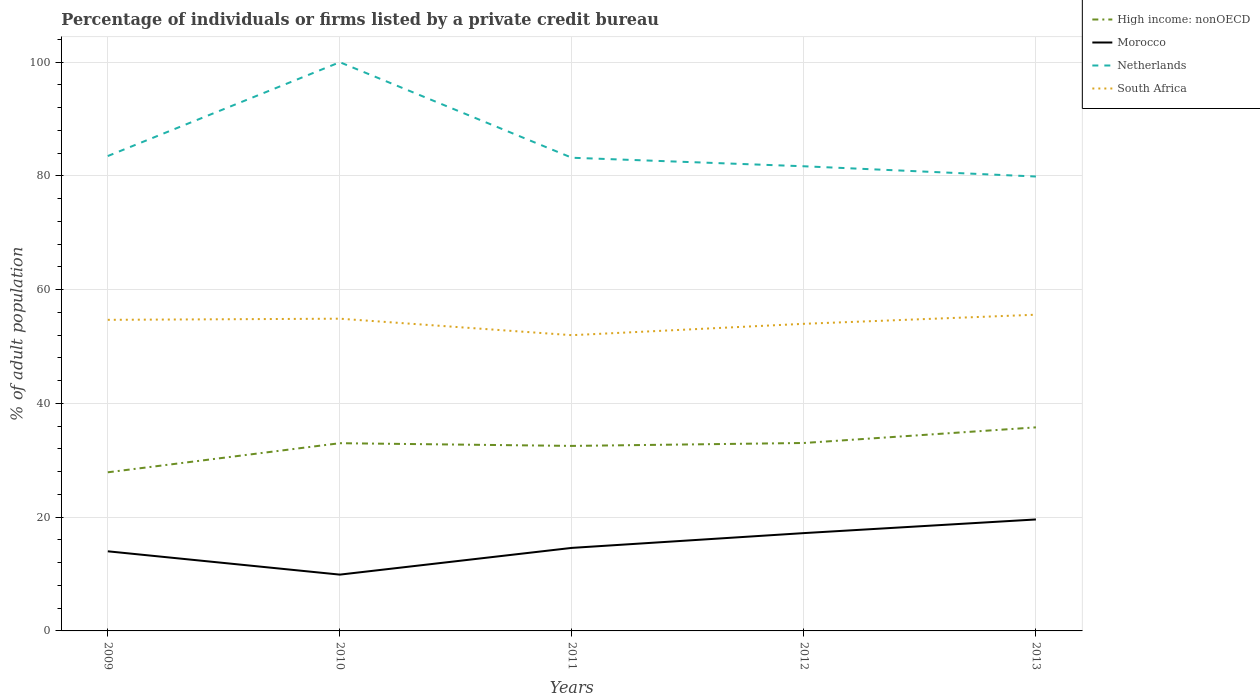How many different coloured lines are there?
Make the answer very short. 4. Across all years, what is the maximum percentage of population listed by a private credit bureau in Morocco?
Provide a succinct answer. 9.9. In which year was the percentage of population listed by a private credit bureau in Netherlands maximum?
Your response must be concise. 2013. What is the total percentage of population listed by a private credit bureau in High income: nonOECD in the graph?
Make the answer very short. -2.78. What is the difference between the highest and the second highest percentage of population listed by a private credit bureau in Netherlands?
Offer a very short reply. 20.1. What is the difference between the highest and the lowest percentage of population listed by a private credit bureau in South Africa?
Give a very brief answer. 3. Is the percentage of population listed by a private credit bureau in High income: nonOECD strictly greater than the percentage of population listed by a private credit bureau in Morocco over the years?
Your answer should be compact. No. How many lines are there?
Make the answer very short. 4. Are the values on the major ticks of Y-axis written in scientific E-notation?
Provide a succinct answer. No. What is the title of the graph?
Your answer should be compact. Percentage of individuals or firms listed by a private credit bureau. Does "Bahrain" appear as one of the legend labels in the graph?
Keep it short and to the point. No. What is the label or title of the X-axis?
Keep it short and to the point. Years. What is the label or title of the Y-axis?
Offer a terse response. % of adult population. What is the % of adult population of High income: nonOECD in 2009?
Offer a terse response. 27.89. What is the % of adult population in Morocco in 2009?
Your answer should be very brief. 14. What is the % of adult population in Netherlands in 2009?
Make the answer very short. 83.5. What is the % of adult population of South Africa in 2009?
Provide a short and direct response. 54.7. What is the % of adult population of High income: nonOECD in 2010?
Your response must be concise. 33.01. What is the % of adult population in Morocco in 2010?
Give a very brief answer. 9.9. What is the % of adult population in Netherlands in 2010?
Give a very brief answer. 100. What is the % of adult population in South Africa in 2010?
Provide a short and direct response. 54.9. What is the % of adult population of High income: nonOECD in 2011?
Keep it short and to the point. 32.53. What is the % of adult population of Morocco in 2011?
Ensure brevity in your answer.  14.6. What is the % of adult population in Netherlands in 2011?
Make the answer very short. 83.2. What is the % of adult population of South Africa in 2011?
Your answer should be very brief. 52. What is the % of adult population in High income: nonOECD in 2012?
Provide a short and direct response. 33.04. What is the % of adult population of Netherlands in 2012?
Your answer should be compact. 81.7. What is the % of adult population of South Africa in 2012?
Your response must be concise. 54. What is the % of adult population in High income: nonOECD in 2013?
Keep it short and to the point. 35.79. What is the % of adult population in Morocco in 2013?
Provide a succinct answer. 19.6. What is the % of adult population in Netherlands in 2013?
Your answer should be very brief. 79.9. What is the % of adult population in South Africa in 2013?
Provide a succinct answer. 55.6. Across all years, what is the maximum % of adult population of High income: nonOECD?
Ensure brevity in your answer.  35.79. Across all years, what is the maximum % of adult population of Morocco?
Provide a short and direct response. 19.6. Across all years, what is the maximum % of adult population in South Africa?
Your answer should be compact. 55.6. Across all years, what is the minimum % of adult population in High income: nonOECD?
Your response must be concise. 27.89. Across all years, what is the minimum % of adult population of Morocco?
Make the answer very short. 9.9. Across all years, what is the minimum % of adult population in Netherlands?
Keep it short and to the point. 79.9. What is the total % of adult population of High income: nonOECD in the graph?
Offer a very short reply. 162.27. What is the total % of adult population of Morocco in the graph?
Provide a succinct answer. 75.3. What is the total % of adult population in Netherlands in the graph?
Give a very brief answer. 428.3. What is the total % of adult population in South Africa in the graph?
Make the answer very short. 271.2. What is the difference between the % of adult population of High income: nonOECD in 2009 and that in 2010?
Keep it short and to the point. -5.12. What is the difference between the % of adult population in Morocco in 2009 and that in 2010?
Give a very brief answer. 4.1. What is the difference between the % of adult population of Netherlands in 2009 and that in 2010?
Provide a short and direct response. -16.5. What is the difference between the % of adult population of High income: nonOECD in 2009 and that in 2011?
Make the answer very short. -4.64. What is the difference between the % of adult population in Morocco in 2009 and that in 2011?
Your response must be concise. -0.6. What is the difference between the % of adult population in South Africa in 2009 and that in 2011?
Your answer should be compact. 2.7. What is the difference between the % of adult population of High income: nonOECD in 2009 and that in 2012?
Provide a succinct answer. -5.15. What is the difference between the % of adult population in Netherlands in 2009 and that in 2012?
Ensure brevity in your answer.  1.8. What is the difference between the % of adult population in High income: nonOECD in 2009 and that in 2013?
Offer a terse response. -7.9. What is the difference between the % of adult population in Morocco in 2009 and that in 2013?
Give a very brief answer. -5.6. What is the difference between the % of adult population in South Africa in 2009 and that in 2013?
Make the answer very short. -0.9. What is the difference between the % of adult population of High income: nonOECD in 2010 and that in 2011?
Your response must be concise. 0.48. What is the difference between the % of adult population in Netherlands in 2010 and that in 2011?
Your response must be concise. 16.8. What is the difference between the % of adult population of South Africa in 2010 and that in 2011?
Ensure brevity in your answer.  2.9. What is the difference between the % of adult population of High income: nonOECD in 2010 and that in 2012?
Offer a terse response. -0.04. What is the difference between the % of adult population of Netherlands in 2010 and that in 2012?
Provide a short and direct response. 18.3. What is the difference between the % of adult population of High income: nonOECD in 2010 and that in 2013?
Offer a terse response. -2.78. What is the difference between the % of adult population of Netherlands in 2010 and that in 2013?
Offer a very short reply. 20.1. What is the difference between the % of adult population in High income: nonOECD in 2011 and that in 2012?
Your answer should be very brief. -0.51. What is the difference between the % of adult population of Netherlands in 2011 and that in 2012?
Offer a very short reply. 1.5. What is the difference between the % of adult population in South Africa in 2011 and that in 2012?
Keep it short and to the point. -2. What is the difference between the % of adult population in High income: nonOECD in 2011 and that in 2013?
Offer a terse response. -3.26. What is the difference between the % of adult population in Netherlands in 2011 and that in 2013?
Your answer should be compact. 3.3. What is the difference between the % of adult population of South Africa in 2011 and that in 2013?
Make the answer very short. -3.6. What is the difference between the % of adult population in High income: nonOECD in 2012 and that in 2013?
Provide a short and direct response. -2.75. What is the difference between the % of adult population of Morocco in 2012 and that in 2013?
Ensure brevity in your answer.  -2.4. What is the difference between the % of adult population of Netherlands in 2012 and that in 2013?
Ensure brevity in your answer.  1.8. What is the difference between the % of adult population of South Africa in 2012 and that in 2013?
Offer a terse response. -1.6. What is the difference between the % of adult population in High income: nonOECD in 2009 and the % of adult population in Morocco in 2010?
Your answer should be compact. 17.99. What is the difference between the % of adult population of High income: nonOECD in 2009 and the % of adult population of Netherlands in 2010?
Your answer should be very brief. -72.11. What is the difference between the % of adult population in High income: nonOECD in 2009 and the % of adult population in South Africa in 2010?
Provide a succinct answer. -27.01. What is the difference between the % of adult population of Morocco in 2009 and the % of adult population of Netherlands in 2010?
Ensure brevity in your answer.  -86. What is the difference between the % of adult population in Morocco in 2009 and the % of adult population in South Africa in 2010?
Your answer should be very brief. -40.9. What is the difference between the % of adult population in Netherlands in 2009 and the % of adult population in South Africa in 2010?
Your response must be concise. 28.6. What is the difference between the % of adult population of High income: nonOECD in 2009 and the % of adult population of Morocco in 2011?
Offer a terse response. 13.29. What is the difference between the % of adult population of High income: nonOECD in 2009 and the % of adult population of Netherlands in 2011?
Make the answer very short. -55.31. What is the difference between the % of adult population of High income: nonOECD in 2009 and the % of adult population of South Africa in 2011?
Keep it short and to the point. -24.11. What is the difference between the % of adult population in Morocco in 2009 and the % of adult population in Netherlands in 2011?
Offer a terse response. -69.2. What is the difference between the % of adult population in Morocco in 2009 and the % of adult population in South Africa in 2011?
Provide a succinct answer. -38. What is the difference between the % of adult population in Netherlands in 2009 and the % of adult population in South Africa in 2011?
Your answer should be compact. 31.5. What is the difference between the % of adult population in High income: nonOECD in 2009 and the % of adult population in Morocco in 2012?
Your answer should be very brief. 10.69. What is the difference between the % of adult population of High income: nonOECD in 2009 and the % of adult population of Netherlands in 2012?
Make the answer very short. -53.81. What is the difference between the % of adult population in High income: nonOECD in 2009 and the % of adult population in South Africa in 2012?
Offer a very short reply. -26.11. What is the difference between the % of adult population in Morocco in 2009 and the % of adult population in Netherlands in 2012?
Your answer should be compact. -67.7. What is the difference between the % of adult population in Netherlands in 2009 and the % of adult population in South Africa in 2012?
Keep it short and to the point. 29.5. What is the difference between the % of adult population in High income: nonOECD in 2009 and the % of adult population in Morocco in 2013?
Offer a very short reply. 8.29. What is the difference between the % of adult population of High income: nonOECD in 2009 and the % of adult population of Netherlands in 2013?
Your response must be concise. -52.01. What is the difference between the % of adult population of High income: nonOECD in 2009 and the % of adult population of South Africa in 2013?
Keep it short and to the point. -27.71. What is the difference between the % of adult population in Morocco in 2009 and the % of adult population in Netherlands in 2013?
Offer a terse response. -65.9. What is the difference between the % of adult population in Morocco in 2009 and the % of adult population in South Africa in 2013?
Provide a short and direct response. -41.6. What is the difference between the % of adult population of Netherlands in 2009 and the % of adult population of South Africa in 2013?
Offer a very short reply. 27.9. What is the difference between the % of adult population of High income: nonOECD in 2010 and the % of adult population of Morocco in 2011?
Ensure brevity in your answer.  18.41. What is the difference between the % of adult population in High income: nonOECD in 2010 and the % of adult population in Netherlands in 2011?
Offer a terse response. -50.19. What is the difference between the % of adult population in High income: nonOECD in 2010 and the % of adult population in South Africa in 2011?
Your answer should be compact. -18.99. What is the difference between the % of adult population in Morocco in 2010 and the % of adult population in Netherlands in 2011?
Ensure brevity in your answer.  -73.3. What is the difference between the % of adult population of Morocco in 2010 and the % of adult population of South Africa in 2011?
Offer a terse response. -42.1. What is the difference between the % of adult population of High income: nonOECD in 2010 and the % of adult population of Morocco in 2012?
Make the answer very short. 15.81. What is the difference between the % of adult population in High income: nonOECD in 2010 and the % of adult population in Netherlands in 2012?
Make the answer very short. -48.69. What is the difference between the % of adult population in High income: nonOECD in 2010 and the % of adult population in South Africa in 2012?
Your answer should be compact. -20.99. What is the difference between the % of adult population in Morocco in 2010 and the % of adult population in Netherlands in 2012?
Ensure brevity in your answer.  -71.8. What is the difference between the % of adult population in Morocco in 2010 and the % of adult population in South Africa in 2012?
Your answer should be very brief. -44.1. What is the difference between the % of adult population in Netherlands in 2010 and the % of adult population in South Africa in 2012?
Provide a short and direct response. 46. What is the difference between the % of adult population in High income: nonOECD in 2010 and the % of adult population in Morocco in 2013?
Your response must be concise. 13.41. What is the difference between the % of adult population of High income: nonOECD in 2010 and the % of adult population of Netherlands in 2013?
Your answer should be compact. -46.89. What is the difference between the % of adult population in High income: nonOECD in 2010 and the % of adult population in South Africa in 2013?
Your answer should be compact. -22.59. What is the difference between the % of adult population of Morocco in 2010 and the % of adult population of Netherlands in 2013?
Your answer should be compact. -70. What is the difference between the % of adult population in Morocco in 2010 and the % of adult population in South Africa in 2013?
Offer a very short reply. -45.7. What is the difference between the % of adult population in Netherlands in 2010 and the % of adult population in South Africa in 2013?
Provide a short and direct response. 44.4. What is the difference between the % of adult population of High income: nonOECD in 2011 and the % of adult population of Morocco in 2012?
Provide a succinct answer. 15.33. What is the difference between the % of adult population in High income: nonOECD in 2011 and the % of adult population in Netherlands in 2012?
Keep it short and to the point. -49.17. What is the difference between the % of adult population of High income: nonOECD in 2011 and the % of adult population of South Africa in 2012?
Give a very brief answer. -21.47. What is the difference between the % of adult population of Morocco in 2011 and the % of adult population of Netherlands in 2012?
Ensure brevity in your answer.  -67.1. What is the difference between the % of adult population of Morocco in 2011 and the % of adult population of South Africa in 2012?
Your answer should be very brief. -39.4. What is the difference between the % of adult population of Netherlands in 2011 and the % of adult population of South Africa in 2012?
Provide a succinct answer. 29.2. What is the difference between the % of adult population of High income: nonOECD in 2011 and the % of adult population of Morocco in 2013?
Offer a very short reply. 12.93. What is the difference between the % of adult population in High income: nonOECD in 2011 and the % of adult population in Netherlands in 2013?
Provide a short and direct response. -47.37. What is the difference between the % of adult population of High income: nonOECD in 2011 and the % of adult population of South Africa in 2013?
Give a very brief answer. -23.07. What is the difference between the % of adult population of Morocco in 2011 and the % of adult population of Netherlands in 2013?
Provide a succinct answer. -65.3. What is the difference between the % of adult population of Morocco in 2011 and the % of adult population of South Africa in 2013?
Make the answer very short. -41. What is the difference between the % of adult population of Netherlands in 2011 and the % of adult population of South Africa in 2013?
Keep it short and to the point. 27.6. What is the difference between the % of adult population in High income: nonOECD in 2012 and the % of adult population in Morocco in 2013?
Give a very brief answer. 13.44. What is the difference between the % of adult population of High income: nonOECD in 2012 and the % of adult population of Netherlands in 2013?
Offer a terse response. -46.86. What is the difference between the % of adult population in High income: nonOECD in 2012 and the % of adult population in South Africa in 2013?
Ensure brevity in your answer.  -22.56. What is the difference between the % of adult population of Morocco in 2012 and the % of adult population of Netherlands in 2013?
Keep it short and to the point. -62.7. What is the difference between the % of adult population of Morocco in 2012 and the % of adult population of South Africa in 2013?
Offer a terse response. -38.4. What is the difference between the % of adult population in Netherlands in 2012 and the % of adult population in South Africa in 2013?
Your answer should be very brief. 26.1. What is the average % of adult population of High income: nonOECD per year?
Keep it short and to the point. 32.45. What is the average % of adult population of Morocco per year?
Your answer should be very brief. 15.06. What is the average % of adult population in Netherlands per year?
Give a very brief answer. 85.66. What is the average % of adult population in South Africa per year?
Your answer should be very brief. 54.24. In the year 2009, what is the difference between the % of adult population in High income: nonOECD and % of adult population in Morocco?
Offer a very short reply. 13.89. In the year 2009, what is the difference between the % of adult population in High income: nonOECD and % of adult population in Netherlands?
Offer a very short reply. -55.61. In the year 2009, what is the difference between the % of adult population of High income: nonOECD and % of adult population of South Africa?
Give a very brief answer. -26.81. In the year 2009, what is the difference between the % of adult population of Morocco and % of adult population of Netherlands?
Offer a terse response. -69.5. In the year 2009, what is the difference between the % of adult population of Morocco and % of adult population of South Africa?
Provide a short and direct response. -40.7. In the year 2009, what is the difference between the % of adult population in Netherlands and % of adult population in South Africa?
Offer a very short reply. 28.8. In the year 2010, what is the difference between the % of adult population of High income: nonOECD and % of adult population of Morocco?
Give a very brief answer. 23.11. In the year 2010, what is the difference between the % of adult population in High income: nonOECD and % of adult population in Netherlands?
Make the answer very short. -66.99. In the year 2010, what is the difference between the % of adult population in High income: nonOECD and % of adult population in South Africa?
Provide a succinct answer. -21.89. In the year 2010, what is the difference between the % of adult population in Morocco and % of adult population in Netherlands?
Provide a succinct answer. -90.1. In the year 2010, what is the difference between the % of adult population in Morocco and % of adult population in South Africa?
Provide a succinct answer. -45. In the year 2010, what is the difference between the % of adult population in Netherlands and % of adult population in South Africa?
Make the answer very short. 45.1. In the year 2011, what is the difference between the % of adult population of High income: nonOECD and % of adult population of Morocco?
Your answer should be compact. 17.93. In the year 2011, what is the difference between the % of adult population of High income: nonOECD and % of adult population of Netherlands?
Make the answer very short. -50.67. In the year 2011, what is the difference between the % of adult population of High income: nonOECD and % of adult population of South Africa?
Give a very brief answer. -19.47. In the year 2011, what is the difference between the % of adult population in Morocco and % of adult population in Netherlands?
Your response must be concise. -68.6. In the year 2011, what is the difference between the % of adult population of Morocco and % of adult population of South Africa?
Your response must be concise. -37.4. In the year 2011, what is the difference between the % of adult population of Netherlands and % of adult population of South Africa?
Give a very brief answer. 31.2. In the year 2012, what is the difference between the % of adult population in High income: nonOECD and % of adult population in Morocco?
Provide a succinct answer. 15.84. In the year 2012, what is the difference between the % of adult population in High income: nonOECD and % of adult population in Netherlands?
Your response must be concise. -48.66. In the year 2012, what is the difference between the % of adult population in High income: nonOECD and % of adult population in South Africa?
Ensure brevity in your answer.  -20.96. In the year 2012, what is the difference between the % of adult population of Morocco and % of adult population of Netherlands?
Your answer should be very brief. -64.5. In the year 2012, what is the difference between the % of adult population of Morocco and % of adult population of South Africa?
Give a very brief answer. -36.8. In the year 2012, what is the difference between the % of adult population in Netherlands and % of adult population in South Africa?
Your answer should be compact. 27.7. In the year 2013, what is the difference between the % of adult population of High income: nonOECD and % of adult population of Morocco?
Your answer should be compact. 16.19. In the year 2013, what is the difference between the % of adult population of High income: nonOECD and % of adult population of Netherlands?
Ensure brevity in your answer.  -44.11. In the year 2013, what is the difference between the % of adult population in High income: nonOECD and % of adult population in South Africa?
Make the answer very short. -19.81. In the year 2013, what is the difference between the % of adult population of Morocco and % of adult population of Netherlands?
Your response must be concise. -60.3. In the year 2013, what is the difference between the % of adult population of Morocco and % of adult population of South Africa?
Your response must be concise. -36. In the year 2013, what is the difference between the % of adult population in Netherlands and % of adult population in South Africa?
Provide a short and direct response. 24.3. What is the ratio of the % of adult population of High income: nonOECD in 2009 to that in 2010?
Your answer should be compact. 0.84. What is the ratio of the % of adult population of Morocco in 2009 to that in 2010?
Keep it short and to the point. 1.41. What is the ratio of the % of adult population of Netherlands in 2009 to that in 2010?
Provide a succinct answer. 0.83. What is the ratio of the % of adult population of South Africa in 2009 to that in 2010?
Your answer should be compact. 1. What is the ratio of the % of adult population in High income: nonOECD in 2009 to that in 2011?
Your answer should be compact. 0.86. What is the ratio of the % of adult population in Morocco in 2009 to that in 2011?
Provide a succinct answer. 0.96. What is the ratio of the % of adult population in Netherlands in 2009 to that in 2011?
Your answer should be compact. 1. What is the ratio of the % of adult population of South Africa in 2009 to that in 2011?
Provide a short and direct response. 1.05. What is the ratio of the % of adult population of High income: nonOECD in 2009 to that in 2012?
Provide a short and direct response. 0.84. What is the ratio of the % of adult population of Morocco in 2009 to that in 2012?
Offer a terse response. 0.81. What is the ratio of the % of adult population in Netherlands in 2009 to that in 2012?
Keep it short and to the point. 1.02. What is the ratio of the % of adult population in High income: nonOECD in 2009 to that in 2013?
Make the answer very short. 0.78. What is the ratio of the % of adult population of Morocco in 2009 to that in 2013?
Provide a succinct answer. 0.71. What is the ratio of the % of adult population in Netherlands in 2009 to that in 2013?
Make the answer very short. 1.05. What is the ratio of the % of adult population in South Africa in 2009 to that in 2013?
Your answer should be very brief. 0.98. What is the ratio of the % of adult population in High income: nonOECD in 2010 to that in 2011?
Offer a terse response. 1.01. What is the ratio of the % of adult population in Morocco in 2010 to that in 2011?
Provide a succinct answer. 0.68. What is the ratio of the % of adult population in Netherlands in 2010 to that in 2011?
Your answer should be very brief. 1.2. What is the ratio of the % of adult population of South Africa in 2010 to that in 2011?
Make the answer very short. 1.06. What is the ratio of the % of adult population of Morocco in 2010 to that in 2012?
Make the answer very short. 0.58. What is the ratio of the % of adult population of Netherlands in 2010 to that in 2012?
Offer a terse response. 1.22. What is the ratio of the % of adult population of South Africa in 2010 to that in 2012?
Give a very brief answer. 1.02. What is the ratio of the % of adult population of High income: nonOECD in 2010 to that in 2013?
Offer a very short reply. 0.92. What is the ratio of the % of adult population of Morocco in 2010 to that in 2013?
Offer a terse response. 0.51. What is the ratio of the % of adult population in Netherlands in 2010 to that in 2013?
Your response must be concise. 1.25. What is the ratio of the % of adult population of South Africa in 2010 to that in 2013?
Offer a very short reply. 0.99. What is the ratio of the % of adult population of High income: nonOECD in 2011 to that in 2012?
Your answer should be compact. 0.98. What is the ratio of the % of adult population of Morocco in 2011 to that in 2012?
Offer a terse response. 0.85. What is the ratio of the % of adult population of Netherlands in 2011 to that in 2012?
Make the answer very short. 1.02. What is the ratio of the % of adult population in South Africa in 2011 to that in 2012?
Make the answer very short. 0.96. What is the ratio of the % of adult population in High income: nonOECD in 2011 to that in 2013?
Offer a terse response. 0.91. What is the ratio of the % of adult population in Morocco in 2011 to that in 2013?
Make the answer very short. 0.74. What is the ratio of the % of adult population in Netherlands in 2011 to that in 2013?
Offer a very short reply. 1.04. What is the ratio of the % of adult population in South Africa in 2011 to that in 2013?
Make the answer very short. 0.94. What is the ratio of the % of adult population of High income: nonOECD in 2012 to that in 2013?
Provide a short and direct response. 0.92. What is the ratio of the % of adult population of Morocco in 2012 to that in 2013?
Offer a very short reply. 0.88. What is the ratio of the % of adult population of Netherlands in 2012 to that in 2013?
Give a very brief answer. 1.02. What is the ratio of the % of adult population of South Africa in 2012 to that in 2013?
Make the answer very short. 0.97. What is the difference between the highest and the second highest % of adult population in High income: nonOECD?
Your response must be concise. 2.75. What is the difference between the highest and the second highest % of adult population in Netherlands?
Ensure brevity in your answer.  16.5. What is the difference between the highest and the lowest % of adult population in High income: nonOECD?
Provide a succinct answer. 7.9. What is the difference between the highest and the lowest % of adult population of Netherlands?
Provide a succinct answer. 20.1. 